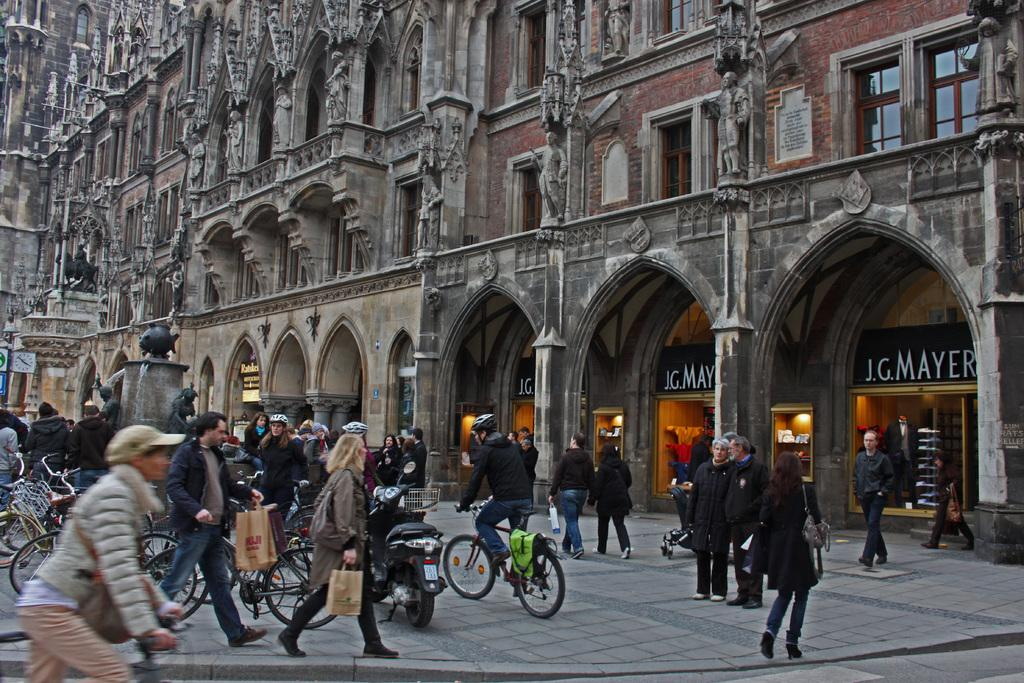What are the people in the image doing? The people in the image are walking and riding bicycles. Where are the people located? The people are on a road. What can be seen in the background of the image? There is a large building in the background of the image. What feature of the building is mentioned? The building has windows. What type of alarm can be heard going off in the image? There is no alarm present in the image, and therefore no such sound can be heard. 